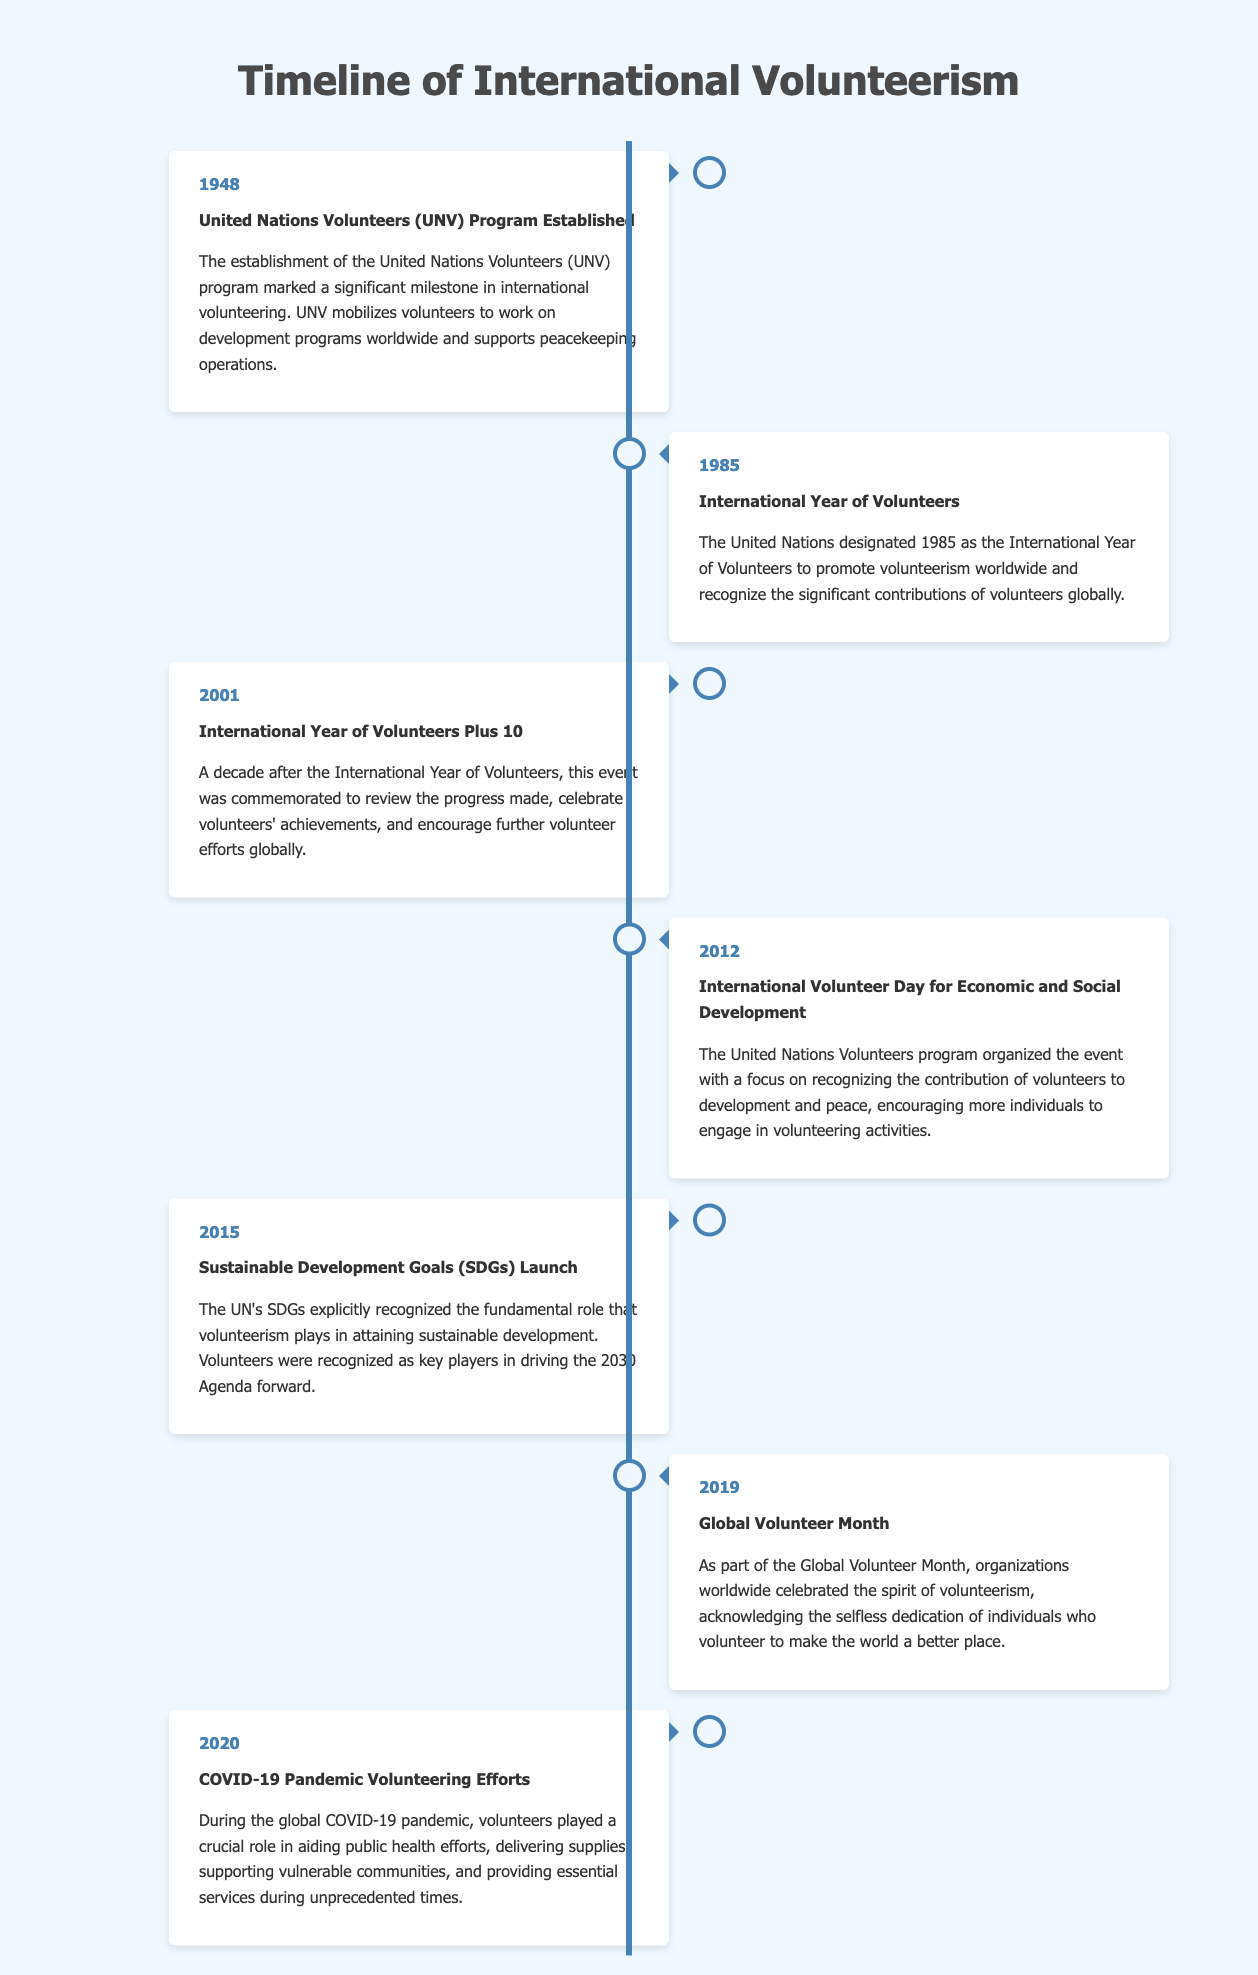What year was the United Nations Volunteers program established? The document states that the UNV program was established in 1948.
Answer: 1948 What was designated as the International Year of Volunteers? The UN designated 1985 as the International Year of Volunteers according to the event listed in the document.
Answer: 1985 What event took place in 2015 related to sustainable development? The document mentions that the Sustainable Development Goals (SDGs) were launched in 2015.
Answer: SDGs Launch What role did volunteers play during the COVID-19 pandemic? The document notes that volunteers aided public health efforts during the COVID-19 pandemic.
Answer: Aided public health efforts In which year was the International Year of Volunteers Plus 10 commemorated? According to the document, the International Year of Volunteers Plus 10 was commemorated in 2001.
Answer: 2001 What major global event was celebrated in April 2019? The document indicates that April 2019 was observed as Global Volunteer Month.
Answer: Global Volunteer Month How often is International Volunteer Day organized? Based on the timeline, International Volunteer Day is held annually; the document specifically highlights the event in 2012.
Answer: Annually What entity organized the International Volunteer Day for Economic and Social Development in 2012? The document states that the United Nations Volunteers program organized this event in 2012.
Answer: United Nations Volunteers program 